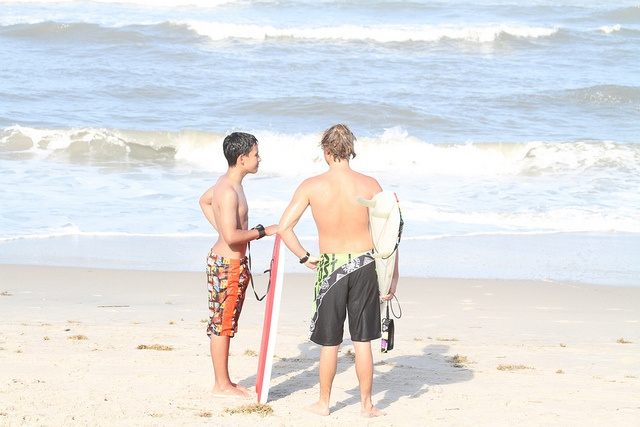Describe the objects in this image and their specific colors. I can see people in white, tan, ivory, and gray tones, people in white, tan, lightgray, and gray tones, surfboard in white and salmon tones, and surfboard in white, ivory, beige, darkgray, and tan tones in this image. 